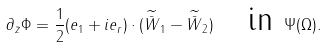<formula> <loc_0><loc_0><loc_500><loc_500>\partial _ { \bar { z } } \Phi = \frac { 1 } { 2 } ( e _ { 1 } + i e _ { r } ) \cdot ( \widetilde { \bar { W } } _ { 1 } - \widetilde { \bar { W } } _ { 2 } ) \quad \text {in } \Psi ( \Omega ) .</formula> 